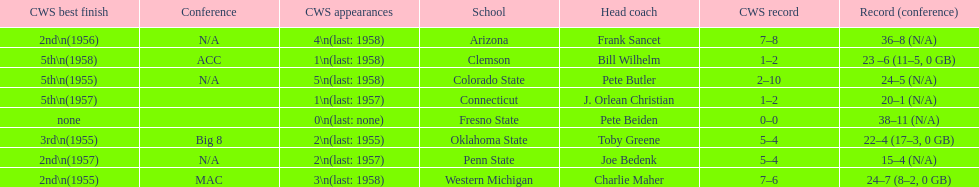How many teams had their cws best finish in 1955? 3. 